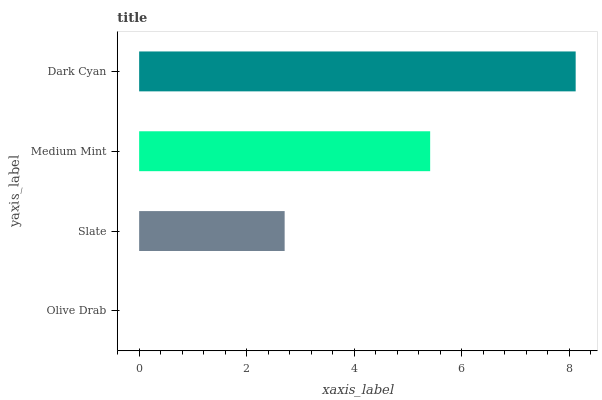Is Olive Drab the minimum?
Answer yes or no. Yes. Is Dark Cyan the maximum?
Answer yes or no. Yes. Is Slate the minimum?
Answer yes or no. No. Is Slate the maximum?
Answer yes or no. No. Is Slate greater than Olive Drab?
Answer yes or no. Yes. Is Olive Drab less than Slate?
Answer yes or no. Yes. Is Olive Drab greater than Slate?
Answer yes or no. No. Is Slate less than Olive Drab?
Answer yes or no. No. Is Medium Mint the high median?
Answer yes or no. Yes. Is Slate the low median?
Answer yes or no. Yes. Is Slate the high median?
Answer yes or no. No. Is Olive Drab the low median?
Answer yes or no. No. 